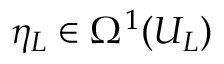<formula> <loc_0><loc_0><loc_500><loc_500>\eta _ { L } \in \Omega ^ { 1 } ( U _ { L } )</formula> 